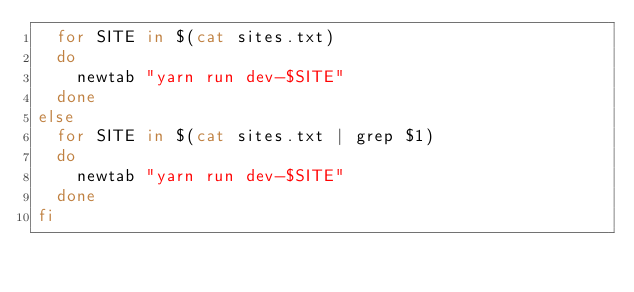<code> <loc_0><loc_0><loc_500><loc_500><_Bash_>  for SITE in $(cat sites.txt)
  do
    newtab "yarn run dev-$SITE"
  done
else
  for SITE in $(cat sites.txt | grep $1)
  do
    newtab "yarn run dev-$SITE"
  done
fi
</code> 